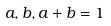Convert formula to latex. <formula><loc_0><loc_0><loc_500><loc_500>a , b , a + b = 1</formula> 